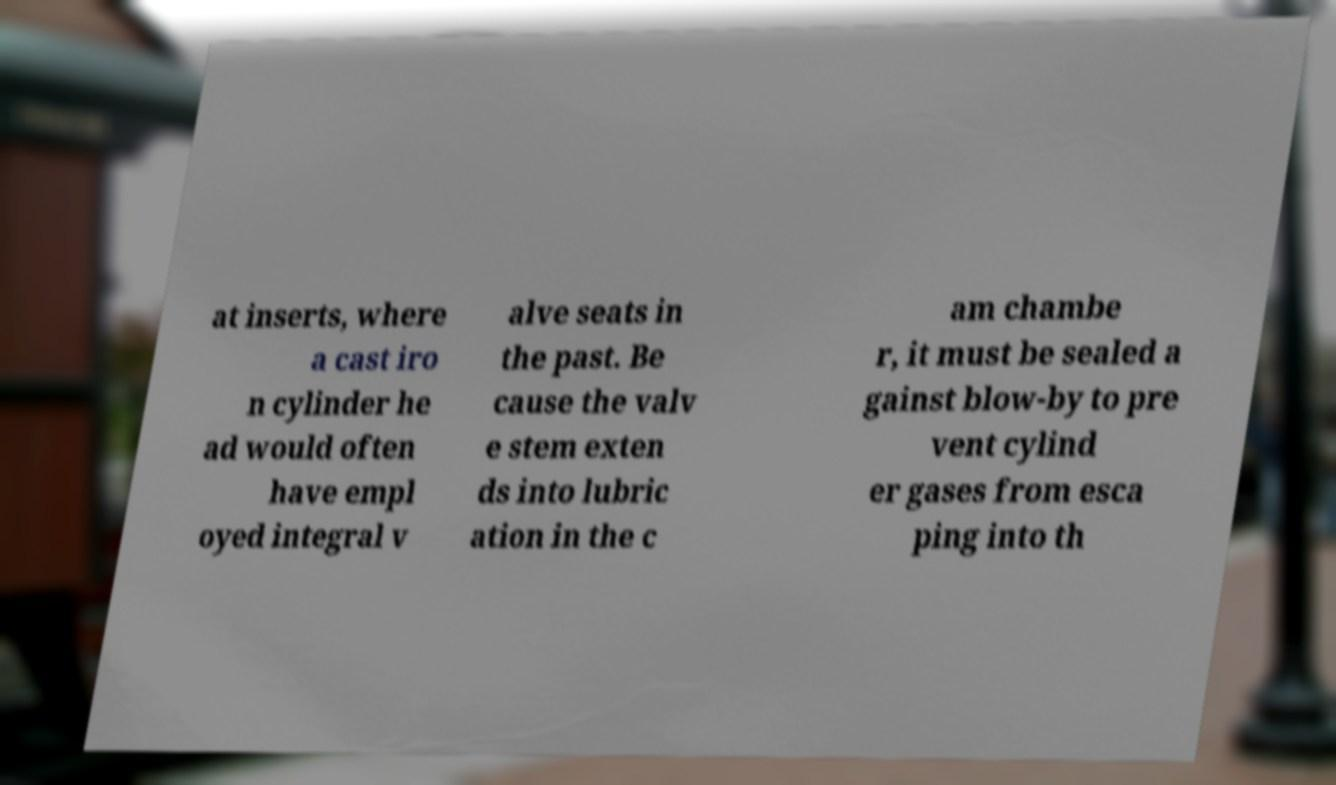Please read and relay the text visible in this image. What does it say? at inserts, where a cast iro n cylinder he ad would often have empl oyed integral v alve seats in the past. Be cause the valv e stem exten ds into lubric ation in the c am chambe r, it must be sealed a gainst blow-by to pre vent cylind er gases from esca ping into th 